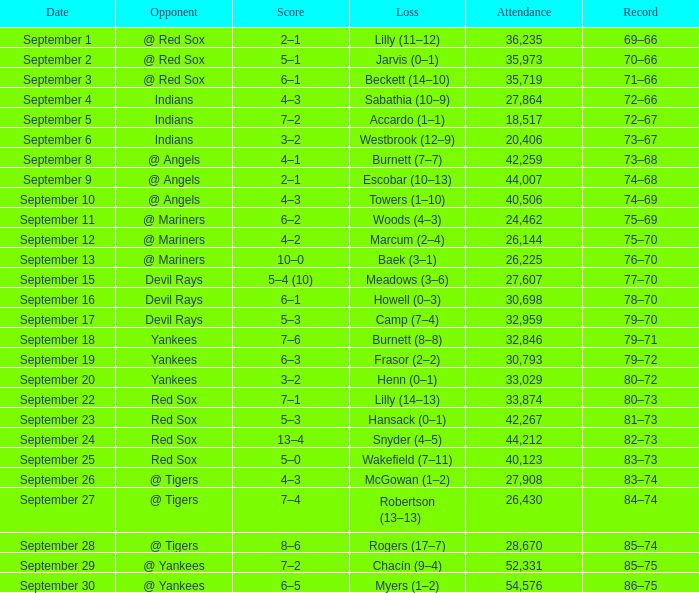Which opponent plays on September 19? Yankees. 